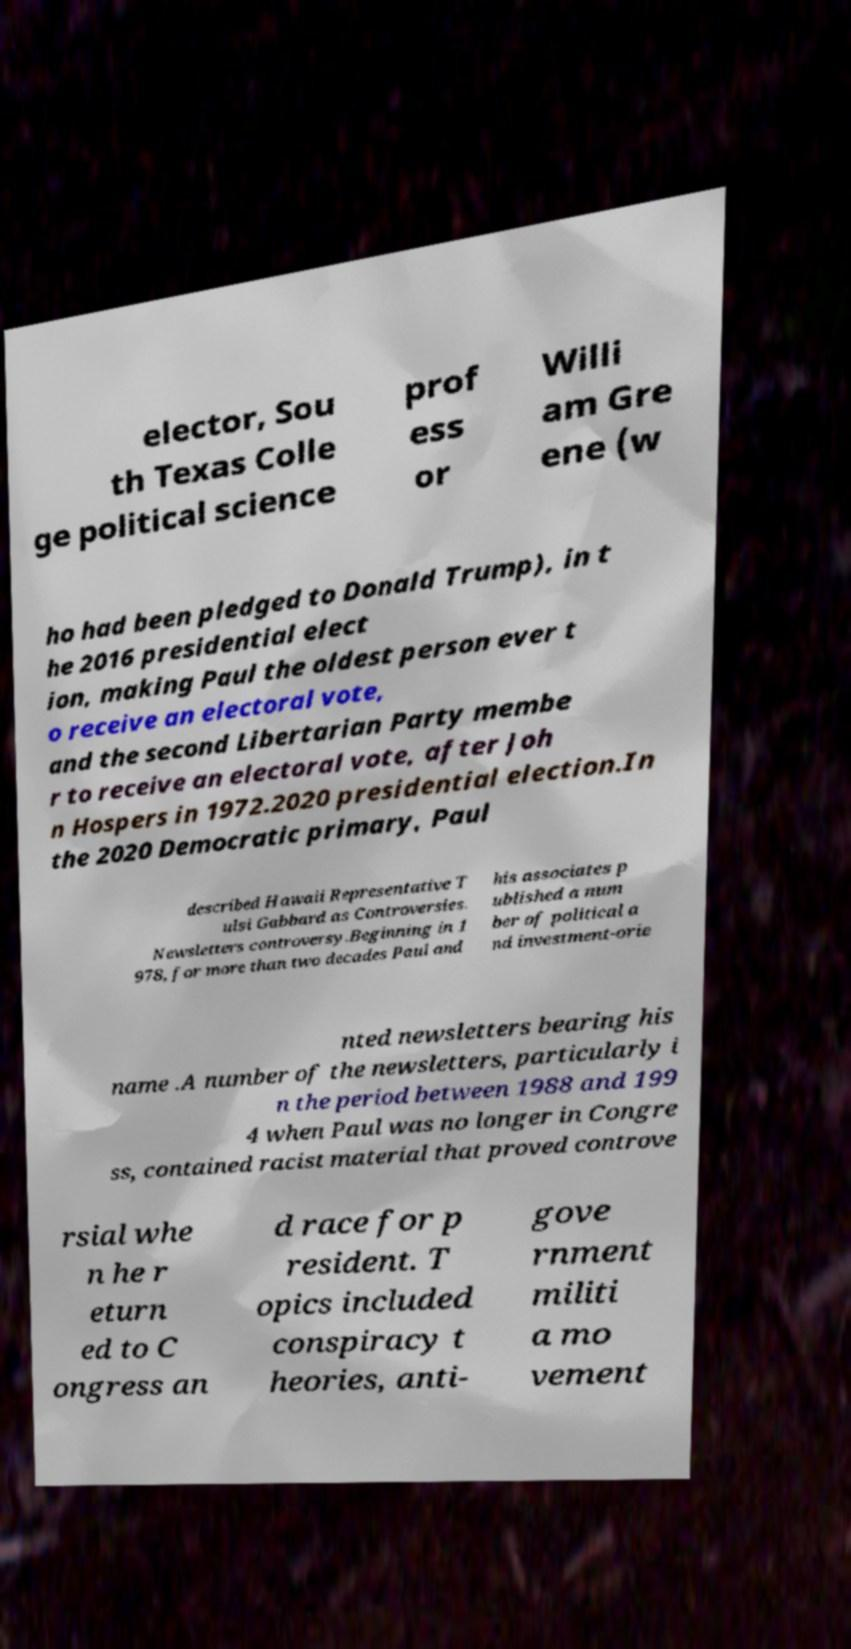Can you read and provide the text displayed in the image?This photo seems to have some interesting text. Can you extract and type it out for me? elector, Sou th Texas Colle ge political science prof ess or Willi am Gre ene (w ho had been pledged to Donald Trump), in t he 2016 presidential elect ion, making Paul the oldest person ever t o receive an electoral vote, and the second Libertarian Party membe r to receive an electoral vote, after Joh n Hospers in 1972.2020 presidential election.In the 2020 Democratic primary, Paul described Hawaii Representative T ulsi Gabbard as Controversies. Newsletters controversy.Beginning in 1 978, for more than two decades Paul and his associates p ublished a num ber of political a nd investment-orie nted newsletters bearing his name .A number of the newsletters, particularly i n the period between 1988 and 199 4 when Paul was no longer in Congre ss, contained racist material that proved controve rsial whe n he r eturn ed to C ongress an d race for p resident. T opics included conspiracy t heories, anti- gove rnment militi a mo vement 